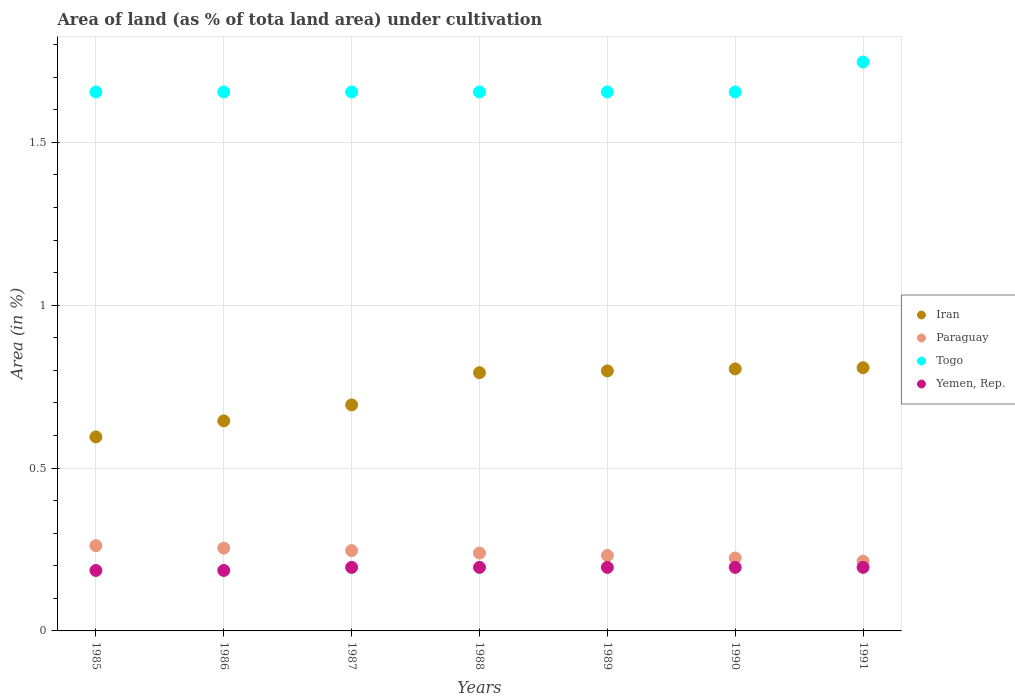How many different coloured dotlines are there?
Provide a succinct answer. 4. Is the number of dotlines equal to the number of legend labels?
Give a very brief answer. Yes. What is the percentage of land under cultivation in Yemen, Rep. in 1989?
Keep it short and to the point. 0.2. Across all years, what is the maximum percentage of land under cultivation in Paraguay?
Your response must be concise. 0.26. Across all years, what is the minimum percentage of land under cultivation in Togo?
Provide a succinct answer. 1.65. In which year was the percentage of land under cultivation in Togo minimum?
Your answer should be compact. 1985. What is the total percentage of land under cultivation in Iran in the graph?
Your response must be concise. 5.14. What is the difference between the percentage of land under cultivation in Iran in 1987 and that in 1991?
Make the answer very short. -0.11. What is the difference between the percentage of land under cultivation in Paraguay in 1985 and the percentage of land under cultivation in Yemen, Rep. in 1986?
Offer a terse response. 0.08. What is the average percentage of land under cultivation in Paraguay per year?
Keep it short and to the point. 0.24. In the year 1986, what is the difference between the percentage of land under cultivation in Yemen, Rep. and percentage of land under cultivation in Paraguay?
Make the answer very short. -0.07. In how many years, is the percentage of land under cultivation in Yemen, Rep. greater than 1.4 %?
Your answer should be compact. 0. What is the ratio of the percentage of land under cultivation in Paraguay in 1990 to that in 1991?
Your answer should be compact. 1.05. Is the difference between the percentage of land under cultivation in Yemen, Rep. in 1988 and 1989 greater than the difference between the percentage of land under cultivation in Paraguay in 1988 and 1989?
Your answer should be compact. No. What is the difference between the highest and the second highest percentage of land under cultivation in Iran?
Provide a short and direct response. 0. What is the difference between the highest and the lowest percentage of land under cultivation in Yemen, Rep.?
Offer a terse response. 0.01. In how many years, is the percentage of land under cultivation in Yemen, Rep. greater than the average percentage of land under cultivation in Yemen, Rep. taken over all years?
Your response must be concise. 5. Is it the case that in every year, the sum of the percentage of land under cultivation in Yemen, Rep. and percentage of land under cultivation in Togo  is greater than the sum of percentage of land under cultivation in Iran and percentage of land under cultivation in Paraguay?
Offer a very short reply. Yes. Is it the case that in every year, the sum of the percentage of land under cultivation in Iran and percentage of land under cultivation in Togo  is greater than the percentage of land under cultivation in Yemen, Rep.?
Offer a very short reply. Yes. Is the percentage of land under cultivation in Yemen, Rep. strictly greater than the percentage of land under cultivation in Iran over the years?
Keep it short and to the point. No. How many dotlines are there?
Provide a short and direct response. 4. What is the title of the graph?
Offer a very short reply. Area of land (as % of tota land area) under cultivation. What is the label or title of the X-axis?
Your answer should be very brief. Years. What is the label or title of the Y-axis?
Offer a very short reply. Area (in %). What is the Area (in %) in Iran in 1985?
Provide a short and direct response. 0.6. What is the Area (in %) in Paraguay in 1985?
Give a very brief answer. 0.26. What is the Area (in %) of Togo in 1985?
Ensure brevity in your answer.  1.65. What is the Area (in %) of Yemen, Rep. in 1985?
Your answer should be compact. 0.19. What is the Area (in %) of Iran in 1986?
Offer a terse response. 0.64. What is the Area (in %) in Paraguay in 1986?
Provide a succinct answer. 0.25. What is the Area (in %) of Togo in 1986?
Your answer should be very brief. 1.65. What is the Area (in %) of Yemen, Rep. in 1986?
Provide a short and direct response. 0.19. What is the Area (in %) of Iran in 1987?
Give a very brief answer. 0.69. What is the Area (in %) of Paraguay in 1987?
Offer a terse response. 0.25. What is the Area (in %) in Togo in 1987?
Offer a terse response. 1.65. What is the Area (in %) of Yemen, Rep. in 1987?
Your response must be concise. 0.2. What is the Area (in %) of Iran in 1988?
Ensure brevity in your answer.  0.79. What is the Area (in %) of Paraguay in 1988?
Your answer should be very brief. 0.24. What is the Area (in %) in Togo in 1988?
Offer a terse response. 1.65. What is the Area (in %) of Yemen, Rep. in 1988?
Offer a very short reply. 0.2. What is the Area (in %) in Iran in 1989?
Provide a succinct answer. 0.8. What is the Area (in %) of Paraguay in 1989?
Give a very brief answer. 0.23. What is the Area (in %) in Togo in 1989?
Your answer should be compact. 1.65. What is the Area (in %) in Yemen, Rep. in 1989?
Keep it short and to the point. 0.2. What is the Area (in %) in Iran in 1990?
Make the answer very short. 0.8. What is the Area (in %) of Paraguay in 1990?
Provide a short and direct response. 0.22. What is the Area (in %) of Togo in 1990?
Give a very brief answer. 1.65. What is the Area (in %) in Yemen, Rep. in 1990?
Keep it short and to the point. 0.2. What is the Area (in %) of Iran in 1991?
Your response must be concise. 0.81. What is the Area (in %) of Paraguay in 1991?
Give a very brief answer. 0.21. What is the Area (in %) in Togo in 1991?
Keep it short and to the point. 1.75. What is the Area (in %) of Yemen, Rep. in 1991?
Give a very brief answer. 0.2. Across all years, what is the maximum Area (in %) in Iran?
Give a very brief answer. 0.81. Across all years, what is the maximum Area (in %) in Paraguay?
Ensure brevity in your answer.  0.26. Across all years, what is the maximum Area (in %) of Togo?
Offer a terse response. 1.75. Across all years, what is the maximum Area (in %) in Yemen, Rep.?
Your response must be concise. 0.2. Across all years, what is the minimum Area (in %) in Iran?
Make the answer very short. 0.6. Across all years, what is the minimum Area (in %) in Paraguay?
Give a very brief answer. 0.21. Across all years, what is the minimum Area (in %) of Togo?
Your answer should be compact. 1.65. Across all years, what is the minimum Area (in %) of Yemen, Rep.?
Offer a very short reply. 0.19. What is the total Area (in %) in Iran in the graph?
Keep it short and to the point. 5.14. What is the total Area (in %) of Paraguay in the graph?
Provide a short and direct response. 1.67. What is the total Area (in %) in Togo in the graph?
Ensure brevity in your answer.  11.67. What is the total Area (in %) in Yemen, Rep. in the graph?
Provide a short and direct response. 1.35. What is the difference between the Area (in %) of Iran in 1985 and that in 1986?
Provide a short and direct response. -0.05. What is the difference between the Area (in %) of Paraguay in 1985 and that in 1986?
Your answer should be very brief. 0.01. What is the difference between the Area (in %) in Yemen, Rep. in 1985 and that in 1986?
Offer a very short reply. 0. What is the difference between the Area (in %) of Iran in 1985 and that in 1987?
Keep it short and to the point. -0.1. What is the difference between the Area (in %) of Paraguay in 1985 and that in 1987?
Provide a succinct answer. 0.02. What is the difference between the Area (in %) in Togo in 1985 and that in 1987?
Provide a succinct answer. 0. What is the difference between the Area (in %) of Yemen, Rep. in 1985 and that in 1987?
Your answer should be compact. -0.01. What is the difference between the Area (in %) of Iran in 1985 and that in 1988?
Your answer should be compact. -0.2. What is the difference between the Area (in %) in Paraguay in 1985 and that in 1988?
Provide a succinct answer. 0.02. What is the difference between the Area (in %) of Togo in 1985 and that in 1988?
Offer a terse response. 0. What is the difference between the Area (in %) in Yemen, Rep. in 1985 and that in 1988?
Provide a succinct answer. -0.01. What is the difference between the Area (in %) in Iran in 1985 and that in 1989?
Your answer should be very brief. -0.2. What is the difference between the Area (in %) of Paraguay in 1985 and that in 1989?
Provide a succinct answer. 0.03. What is the difference between the Area (in %) of Togo in 1985 and that in 1989?
Give a very brief answer. 0. What is the difference between the Area (in %) in Yemen, Rep. in 1985 and that in 1989?
Make the answer very short. -0.01. What is the difference between the Area (in %) of Iran in 1985 and that in 1990?
Provide a succinct answer. -0.21. What is the difference between the Area (in %) of Paraguay in 1985 and that in 1990?
Provide a short and direct response. 0.04. What is the difference between the Area (in %) of Yemen, Rep. in 1985 and that in 1990?
Provide a succinct answer. -0.01. What is the difference between the Area (in %) of Iran in 1985 and that in 1991?
Give a very brief answer. -0.21. What is the difference between the Area (in %) of Paraguay in 1985 and that in 1991?
Your answer should be very brief. 0.05. What is the difference between the Area (in %) of Togo in 1985 and that in 1991?
Offer a very short reply. -0.09. What is the difference between the Area (in %) in Yemen, Rep. in 1985 and that in 1991?
Your answer should be very brief. -0.01. What is the difference between the Area (in %) in Iran in 1986 and that in 1987?
Give a very brief answer. -0.05. What is the difference between the Area (in %) of Paraguay in 1986 and that in 1987?
Keep it short and to the point. 0.01. What is the difference between the Area (in %) of Togo in 1986 and that in 1987?
Give a very brief answer. 0. What is the difference between the Area (in %) in Yemen, Rep. in 1986 and that in 1987?
Provide a short and direct response. -0.01. What is the difference between the Area (in %) in Iran in 1986 and that in 1988?
Keep it short and to the point. -0.15. What is the difference between the Area (in %) in Paraguay in 1986 and that in 1988?
Offer a very short reply. 0.02. What is the difference between the Area (in %) in Togo in 1986 and that in 1988?
Keep it short and to the point. 0. What is the difference between the Area (in %) in Yemen, Rep. in 1986 and that in 1988?
Keep it short and to the point. -0.01. What is the difference between the Area (in %) of Iran in 1986 and that in 1989?
Give a very brief answer. -0.15. What is the difference between the Area (in %) of Paraguay in 1986 and that in 1989?
Provide a succinct answer. 0.02. What is the difference between the Area (in %) of Yemen, Rep. in 1986 and that in 1989?
Your answer should be very brief. -0.01. What is the difference between the Area (in %) in Iran in 1986 and that in 1990?
Make the answer very short. -0.16. What is the difference between the Area (in %) of Paraguay in 1986 and that in 1990?
Your response must be concise. 0.03. What is the difference between the Area (in %) of Yemen, Rep. in 1986 and that in 1990?
Offer a terse response. -0.01. What is the difference between the Area (in %) in Iran in 1986 and that in 1991?
Your answer should be compact. -0.16. What is the difference between the Area (in %) in Paraguay in 1986 and that in 1991?
Keep it short and to the point. 0.04. What is the difference between the Area (in %) in Togo in 1986 and that in 1991?
Your answer should be very brief. -0.09. What is the difference between the Area (in %) in Yemen, Rep. in 1986 and that in 1991?
Provide a short and direct response. -0.01. What is the difference between the Area (in %) in Iran in 1987 and that in 1988?
Your response must be concise. -0.1. What is the difference between the Area (in %) in Paraguay in 1987 and that in 1988?
Keep it short and to the point. 0.01. What is the difference between the Area (in %) in Togo in 1987 and that in 1988?
Give a very brief answer. 0. What is the difference between the Area (in %) in Iran in 1987 and that in 1989?
Offer a terse response. -0.1. What is the difference between the Area (in %) in Paraguay in 1987 and that in 1989?
Provide a succinct answer. 0.02. What is the difference between the Area (in %) of Togo in 1987 and that in 1989?
Keep it short and to the point. 0. What is the difference between the Area (in %) of Iran in 1987 and that in 1990?
Provide a short and direct response. -0.11. What is the difference between the Area (in %) of Paraguay in 1987 and that in 1990?
Make the answer very short. 0.02. What is the difference between the Area (in %) in Yemen, Rep. in 1987 and that in 1990?
Provide a succinct answer. 0. What is the difference between the Area (in %) in Iran in 1987 and that in 1991?
Offer a terse response. -0.11. What is the difference between the Area (in %) of Paraguay in 1987 and that in 1991?
Offer a terse response. 0.03. What is the difference between the Area (in %) of Togo in 1987 and that in 1991?
Keep it short and to the point. -0.09. What is the difference between the Area (in %) in Iran in 1988 and that in 1989?
Provide a succinct answer. -0.01. What is the difference between the Area (in %) of Paraguay in 1988 and that in 1989?
Your answer should be very brief. 0.01. What is the difference between the Area (in %) in Togo in 1988 and that in 1989?
Provide a short and direct response. 0. What is the difference between the Area (in %) of Yemen, Rep. in 1988 and that in 1989?
Your answer should be very brief. 0. What is the difference between the Area (in %) of Iran in 1988 and that in 1990?
Provide a short and direct response. -0.01. What is the difference between the Area (in %) of Paraguay in 1988 and that in 1990?
Keep it short and to the point. 0.02. What is the difference between the Area (in %) of Iran in 1988 and that in 1991?
Give a very brief answer. -0.02. What is the difference between the Area (in %) of Paraguay in 1988 and that in 1991?
Make the answer very short. 0.03. What is the difference between the Area (in %) in Togo in 1988 and that in 1991?
Ensure brevity in your answer.  -0.09. What is the difference between the Area (in %) of Yemen, Rep. in 1988 and that in 1991?
Make the answer very short. 0. What is the difference between the Area (in %) in Iran in 1989 and that in 1990?
Give a very brief answer. -0.01. What is the difference between the Area (in %) of Paraguay in 1989 and that in 1990?
Offer a terse response. 0.01. What is the difference between the Area (in %) in Iran in 1989 and that in 1991?
Give a very brief answer. -0.01. What is the difference between the Area (in %) in Paraguay in 1989 and that in 1991?
Give a very brief answer. 0.02. What is the difference between the Area (in %) of Togo in 1989 and that in 1991?
Offer a terse response. -0.09. What is the difference between the Area (in %) of Yemen, Rep. in 1989 and that in 1991?
Keep it short and to the point. 0. What is the difference between the Area (in %) of Iran in 1990 and that in 1991?
Your answer should be compact. -0. What is the difference between the Area (in %) of Paraguay in 1990 and that in 1991?
Provide a short and direct response. 0.01. What is the difference between the Area (in %) in Togo in 1990 and that in 1991?
Give a very brief answer. -0.09. What is the difference between the Area (in %) in Iran in 1985 and the Area (in %) in Paraguay in 1986?
Your answer should be very brief. 0.34. What is the difference between the Area (in %) in Iran in 1985 and the Area (in %) in Togo in 1986?
Offer a terse response. -1.06. What is the difference between the Area (in %) in Iran in 1985 and the Area (in %) in Yemen, Rep. in 1986?
Make the answer very short. 0.41. What is the difference between the Area (in %) of Paraguay in 1985 and the Area (in %) of Togo in 1986?
Your response must be concise. -1.39. What is the difference between the Area (in %) in Paraguay in 1985 and the Area (in %) in Yemen, Rep. in 1986?
Your answer should be very brief. 0.08. What is the difference between the Area (in %) in Togo in 1985 and the Area (in %) in Yemen, Rep. in 1986?
Provide a succinct answer. 1.47. What is the difference between the Area (in %) of Iran in 1985 and the Area (in %) of Paraguay in 1987?
Provide a succinct answer. 0.35. What is the difference between the Area (in %) of Iran in 1985 and the Area (in %) of Togo in 1987?
Provide a succinct answer. -1.06. What is the difference between the Area (in %) in Iran in 1985 and the Area (in %) in Yemen, Rep. in 1987?
Provide a succinct answer. 0.4. What is the difference between the Area (in %) of Paraguay in 1985 and the Area (in %) of Togo in 1987?
Offer a terse response. -1.39. What is the difference between the Area (in %) of Paraguay in 1985 and the Area (in %) of Yemen, Rep. in 1987?
Your answer should be compact. 0.07. What is the difference between the Area (in %) in Togo in 1985 and the Area (in %) in Yemen, Rep. in 1987?
Provide a succinct answer. 1.46. What is the difference between the Area (in %) of Iran in 1985 and the Area (in %) of Paraguay in 1988?
Your response must be concise. 0.36. What is the difference between the Area (in %) in Iran in 1985 and the Area (in %) in Togo in 1988?
Keep it short and to the point. -1.06. What is the difference between the Area (in %) of Iran in 1985 and the Area (in %) of Yemen, Rep. in 1988?
Your answer should be very brief. 0.4. What is the difference between the Area (in %) of Paraguay in 1985 and the Area (in %) of Togo in 1988?
Offer a very short reply. -1.39. What is the difference between the Area (in %) of Paraguay in 1985 and the Area (in %) of Yemen, Rep. in 1988?
Offer a very short reply. 0.07. What is the difference between the Area (in %) in Togo in 1985 and the Area (in %) in Yemen, Rep. in 1988?
Give a very brief answer. 1.46. What is the difference between the Area (in %) of Iran in 1985 and the Area (in %) of Paraguay in 1989?
Provide a short and direct response. 0.36. What is the difference between the Area (in %) in Iran in 1985 and the Area (in %) in Togo in 1989?
Your answer should be very brief. -1.06. What is the difference between the Area (in %) in Iran in 1985 and the Area (in %) in Yemen, Rep. in 1989?
Make the answer very short. 0.4. What is the difference between the Area (in %) of Paraguay in 1985 and the Area (in %) of Togo in 1989?
Offer a terse response. -1.39. What is the difference between the Area (in %) in Paraguay in 1985 and the Area (in %) in Yemen, Rep. in 1989?
Provide a succinct answer. 0.07. What is the difference between the Area (in %) in Togo in 1985 and the Area (in %) in Yemen, Rep. in 1989?
Keep it short and to the point. 1.46. What is the difference between the Area (in %) in Iran in 1985 and the Area (in %) in Paraguay in 1990?
Give a very brief answer. 0.37. What is the difference between the Area (in %) in Iran in 1985 and the Area (in %) in Togo in 1990?
Offer a terse response. -1.06. What is the difference between the Area (in %) in Iran in 1985 and the Area (in %) in Yemen, Rep. in 1990?
Make the answer very short. 0.4. What is the difference between the Area (in %) of Paraguay in 1985 and the Area (in %) of Togo in 1990?
Make the answer very short. -1.39. What is the difference between the Area (in %) in Paraguay in 1985 and the Area (in %) in Yemen, Rep. in 1990?
Ensure brevity in your answer.  0.07. What is the difference between the Area (in %) in Togo in 1985 and the Area (in %) in Yemen, Rep. in 1990?
Ensure brevity in your answer.  1.46. What is the difference between the Area (in %) of Iran in 1985 and the Area (in %) of Paraguay in 1991?
Offer a very short reply. 0.38. What is the difference between the Area (in %) in Iran in 1985 and the Area (in %) in Togo in 1991?
Give a very brief answer. -1.15. What is the difference between the Area (in %) of Iran in 1985 and the Area (in %) of Yemen, Rep. in 1991?
Offer a terse response. 0.4. What is the difference between the Area (in %) of Paraguay in 1985 and the Area (in %) of Togo in 1991?
Ensure brevity in your answer.  -1.48. What is the difference between the Area (in %) in Paraguay in 1985 and the Area (in %) in Yemen, Rep. in 1991?
Your answer should be very brief. 0.07. What is the difference between the Area (in %) in Togo in 1985 and the Area (in %) in Yemen, Rep. in 1991?
Offer a terse response. 1.46. What is the difference between the Area (in %) of Iran in 1986 and the Area (in %) of Paraguay in 1987?
Offer a very short reply. 0.4. What is the difference between the Area (in %) of Iran in 1986 and the Area (in %) of Togo in 1987?
Your answer should be very brief. -1.01. What is the difference between the Area (in %) of Iran in 1986 and the Area (in %) of Yemen, Rep. in 1987?
Your answer should be very brief. 0.45. What is the difference between the Area (in %) in Paraguay in 1986 and the Area (in %) in Togo in 1987?
Offer a very short reply. -1.4. What is the difference between the Area (in %) in Paraguay in 1986 and the Area (in %) in Yemen, Rep. in 1987?
Keep it short and to the point. 0.06. What is the difference between the Area (in %) in Togo in 1986 and the Area (in %) in Yemen, Rep. in 1987?
Ensure brevity in your answer.  1.46. What is the difference between the Area (in %) in Iran in 1986 and the Area (in %) in Paraguay in 1988?
Give a very brief answer. 0.41. What is the difference between the Area (in %) of Iran in 1986 and the Area (in %) of Togo in 1988?
Your response must be concise. -1.01. What is the difference between the Area (in %) in Iran in 1986 and the Area (in %) in Yemen, Rep. in 1988?
Your answer should be compact. 0.45. What is the difference between the Area (in %) in Paraguay in 1986 and the Area (in %) in Togo in 1988?
Make the answer very short. -1.4. What is the difference between the Area (in %) of Paraguay in 1986 and the Area (in %) of Yemen, Rep. in 1988?
Ensure brevity in your answer.  0.06. What is the difference between the Area (in %) of Togo in 1986 and the Area (in %) of Yemen, Rep. in 1988?
Your response must be concise. 1.46. What is the difference between the Area (in %) of Iran in 1986 and the Area (in %) of Paraguay in 1989?
Offer a very short reply. 0.41. What is the difference between the Area (in %) of Iran in 1986 and the Area (in %) of Togo in 1989?
Provide a short and direct response. -1.01. What is the difference between the Area (in %) in Iran in 1986 and the Area (in %) in Yemen, Rep. in 1989?
Your answer should be very brief. 0.45. What is the difference between the Area (in %) of Paraguay in 1986 and the Area (in %) of Togo in 1989?
Give a very brief answer. -1.4. What is the difference between the Area (in %) of Paraguay in 1986 and the Area (in %) of Yemen, Rep. in 1989?
Make the answer very short. 0.06. What is the difference between the Area (in %) in Togo in 1986 and the Area (in %) in Yemen, Rep. in 1989?
Offer a terse response. 1.46. What is the difference between the Area (in %) of Iran in 1986 and the Area (in %) of Paraguay in 1990?
Provide a succinct answer. 0.42. What is the difference between the Area (in %) in Iran in 1986 and the Area (in %) in Togo in 1990?
Make the answer very short. -1.01. What is the difference between the Area (in %) of Iran in 1986 and the Area (in %) of Yemen, Rep. in 1990?
Make the answer very short. 0.45. What is the difference between the Area (in %) in Paraguay in 1986 and the Area (in %) in Togo in 1990?
Your answer should be compact. -1.4. What is the difference between the Area (in %) of Paraguay in 1986 and the Area (in %) of Yemen, Rep. in 1990?
Your answer should be very brief. 0.06. What is the difference between the Area (in %) in Togo in 1986 and the Area (in %) in Yemen, Rep. in 1990?
Give a very brief answer. 1.46. What is the difference between the Area (in %) in Iran in 1986 and the Area (in %) in Paraguay in 1991?
Your response must be concise. 0.43. What is the difference between the Area (in %) of Iran in 1986 and the Area (in %) of Togo in 1991?
Give a very brief answer. -1.1. What is the difference between the Area (in %) in Iran in 1986 and the Area (in %) in Yemen, Rep. in 1991?
Your response must be concise. 0.45. What is the difference between the Area (in %) of Paraguay in 1986 and the Area (in %) of Togo in 1991?
Offer a very short reply. -1.49. What is the difference between the Area (in %) of Paraguay in 1986 and the Area (in %) of Yemen, Rep. in 1991?
Give a very brief answer. 0.06. What is the difference between the Area (in %) of Togo in 1986 and the Area (in %) of Yemen, Rep. in 1991?
Keep it short and to the point. 1.46. What is the difference between the Area (in %) in Iran in 1987 and the Area (in %) in Paraguay in 1988?
Your response must be concise. 0.45. What is the difference between the Area (in %) in Iran in 1987 and the Area (in %) in Togo in 1988?
Your answer should be very brief. -0.96. What is the difference between the Area (in %) in Iran in 1987 and the Area (in %) in Yemen, Rep. in 1988?
Give a very brief answer. 0.5. What is the difference between the Area (in %) in Paraguay in 1987 and the Area (in %) in Togo in 1988?
Offer a very short reply. -1.41. What is the difference between the Area (in %) in Paraguay in 1987 and the Area (in %) in Yemen, Rep. in 1988?
Offer a terse response. 0.05. What is the difference between the Area (in %) of Togo in 1987 and the Area (in %) of Yemen, Rep. in 1988?
Make the answer very short. 1.46. What is the difference between the Area (in %) in Iran in 1987 and the Area (in %) in Paraguay in 1989?
Your response must be concise. 0.46. What is the difference between the Area (in %) in Iran in 1987 and the Area (in %) in Togo in 1989?
Keep it short and to the point. -0.96. What is the difference between the Area (in %) in Iran in 1987 and the Area (in %) in Yemen, Rep. in 1989?
Offer a very short reply. 0.5. What is the difference between the Area (in %) in Paraguay in 1987 and the Area (in %) in Togo in 1989?
Provide a short and direct response. -1.41. What is the difference between the Area (in %) in Paraguay in 1987 and the Area (in %) in Yemen, Rep. in 1989?
Your answer should be compact. 0.05. What is the difference between the Area (in %) in Togo in 1987 and the Area (in %) in Yemen, Rep. in 1989?
Your answer should be compact. 1.46. What is the difference between the Area (in %) of Iran in 1987 and the Area (in %) of Paraguay in 1990?
Offer a very short reply. 0.47. What is the difference between the Area (in %) in Iran in 1987 and the Area (in %) in Togo in 1990?
Give a very brief answer. -0.96. What is the difference between the Area (in %) of Iran in 1987 and the Area (in %) of Yemen, Rep. in 1990?
Your answer should be very brief. 0.5. What is the difference between the Area (in %) in Paraguay in 1987 and the Area (in %) in Togo in 1990?
Provide a succinct answer. -1.41. What is the difference between the Area (in %) of Paraguay in 1987 and the Area (in %) of Yemen, Rep. in 1990?
Provide a short and direct response. 0.05. What is the difference between the Area (in %) in Togo in 1987 and the Area (in %) in Yemen, Rep. in 1990?
Keep it short and to the point. 1.46. What is the difference between the Area (in %) in Iran in 1987 and the Area (in %) in Paraguay in 1991?
Your answer should be very brief. 0.48. What is the difference between the Area (in %) of Iran in 1987 and the Area (in %) of Togo in 1991?
Provide a short and direct response. -1.05. What is the difference between the Area (in %) of Iran in 1987 and the Area (in %) of Yemen, Rep. in 1991?
Your answer should be compact. 0.5. What is the difference between the Area (in %) in Paraguay in 1987 and the Area (in %) in Yemen, Rep. in 1991?
Offer a very short reply. 0.05. What is the difference between the Area (in %) of Togo in 1987 and the Area (in %) of Yemen, Rep. in 1991?
Your answer should be compact. 1.46. What is the difference between the Area (in %) of Iran in 1988 and the Area (in %) of Paraguay in 1989?
Your response must be concise. 0.56. What is the difference between the Area (in %) of Iran in 1988 and the Area (in %) of Togo in 1989?
Your answer should be very brief. -0.86. What is the difference between the Area (in %) in Iran in 1988 and the Area (in %) in Yemen, Rep. in 1989?
Offer a very short reply. 0.6. What is the difference between the Area (in %) of Paraguay in 1988 and the Area (in %) of Togo in 1989?
Your response must be concise. -1.42. What is the difference between the Area (in %) in Paraguay in 1988 and the Area (in %) in Yemen, Rep. in 1989?
Make the answer very short. 0.04. What is the difference between the Area (in %) of Togo in 1988 and the Area (in %) of Yemen, Rep. in 1989?
Keep it short and to the point. 1.46. What is the difference between the Area (in %) of Iran in 1988 and the Area (in %) of Paraguay in 1990?
Your answer should be compact. 0.57. What is the difference between the Area (in %) of Iran in 1988 and the Area (in %) of Togo in 1990?
Your response must be concise. -0.86. What is the difference between the Area (in %) of Iran in 1988 and the Area (in %) of Yemen, Rep. in 1990?
Give a very brief answer. 0.6. What is the difference between the Area (in %) of Paraguay in 1988 and the Area (in %) of Togo in 1990?
Provide a succinct answer. -1.42. What is the difference between the Area (in %) of Paraguay in 1988 and the Area (in %) of Yemen, Rep. in 1990?
Offer a terse response. 0.04. What is the difference between the Area (in %) of Togo in 1988 and the Area (in %) of Yemen, Rep. in 1990?
Provide a short and direct response. 1.46. What is the difference between the Area (in %) of Iran in 1988 and the Area (in %) of Paraguay in 1991?
Keep it short and to the point. 0.58. What is the difference between the Area (in %) of Iran in 1988 and the Area (in %) of Togo in 1991?
Provide a succinct answer. -0.95. What is the difference between the Area (in %) of Iran in 1988 and the Area (in %) of Yemen, Rep. in 1991?
Your answer should be very brief. 0.6. What is the difference between the Area (in %) of Paraguay in 1988 and the Area (in %) of Togo in 1991?
Give a very brief answer. -1.51. What is the difference between the Area (in %) in Paraguay in 1988 and the Area (in %) in Yemen, Rep. in 1991?
Offer a very short reply. 0.04. What is the difference between the Area (in %) in Togo in 1988 and the Area (in %) in Yemen, Rep. in 1991?
Offer a very short reply. 1.46. What is the difference between the Area (in %) in Iran in 1989 and the Area (in %) in Paraguay in 1990?
Offer a very short reply. 0.57. What is the difference between the Area (in %) of Iran in 1989 and the Area (in %) of Togo in 1990?
Keep it short and to the point. -0.86. What is the difference between the Area (in %) in Iran in 1989 and the Area (in %) in Yemen, Rep. in 1990?
Your answer should be very brief. 0.6. What is the difference between the Area (in %) in Paraguay in 1989 and the Area (in %) in Togo in 1990?
Offer a terse response. -1.42. What is the difference between the Area (in %) in Paraguay in 1989 and the Area (in %) in Yemen, Rep. in 1990?
Provide a succinct answer. 0.04. What is the difference between the Area (in %) of Togo in 1989 and the Area (in %) of Yemen, Rep. in 1990?
Provide a succinct answer. 1.46. What is the difference between the Area (in %) of Iran in 1989 and the Area (in %) of Paraguay in 1991?
Provide a short and direct response. 0.58. What is the difference between the Area (in %) of Iran in 1989 and the Area (in %) of Togo in 1991?
Your answer should be compact. -0.95. What is the difference between the Area (in %) in Iran in 1989 and the Area (in %) in Yemen, Rep. in 1991?
Your answer should be very brief. 0.6. What is the difference between the Area (in %) in Paraguay in 1989 and the Area (in %) in Togo in 1991?
Your answer should be compact. -1.52. What is the difference between the Area (in %) of Paraguay in 1989 and the Area (in %) of Yemen, Rep. in 1991?
Your answer should be very brief. 0.04. What is the difference between the Area (in %) of Togo in 1989 and the Area (in %) of Yemen, Rep. in 1991?
Give a very brief answer. 1.46. What is the difference between the Area (in %) in Iran in 1990 and the Area (in %) in Paraguay in 1991?
Make the answer very short. 0.59. What is the difference between the Area (in %) of Iran in 1990 and the Area (in %) of Togo in 1991?
Offer a very short reply. -0.94. What is the difference between the Area (in %) of Iran in 1990 and the Area (in %) of Yemen, Rep. in 1991?
Keep it short and to the point. 0.61. What is the difference between the Area (in %) in Paraguay in 1990 and the Area (in %) in Togo in 1991?
Make the answer very short. -1.52. What is the difference between the Area (in %) in Paraguay in 1990 and the Area (in %) in Yemen, Rep. in 1991?
Your response must be concise. 0.03. What is the difference between the Area (in %) in Togo in 1990 and the Area (in %) in Yemen, Rep. in 1991?
Provide a succinct answer. 1.46. What is the average Area (in %) in Iran per year?
Give a very brief answer. 0.73. What is the average Area (in %) in Paraguay per year?
Offer a very short reply. 0.24. What is the average Area (in %) in Togo per year?
Your answer should be very brief. 1.67. What is the average Area (in %) in Yemen, Rep. per year?
Offer a terse response. 0.19. In the year 1985, what is the difference between the Area (in %) in Iran and Area (in %) in Paraguay?
Your answer should be compact. 0.33. In the year 1985, what is the difference between the Area (in %) of Iran and Area (in %) of Togo?
Offer a terse response. -1.06. In the year 1985, what is the difference between the Area (in %) of Iran and Area (in %) of Yemen, Rep.?
Ensure brevity in your answer.  0.41. In the year 1985, what is the difference between the Area (in %) in Paraguay and Area (in %) in Togo?
Your response must be concise. -1.39. In the year 1985, what is the difference between the Area (in %) of Paraguay and Area (in %) of Yemen, Rep.?
Offer a terse response. 0.08. In the year 1985, what is the difference between the Area (in %) of Togo and Area (in %) of Yemen, Rep.?
Provide a succinct answer. 1.47. In the year 1986, what is the difference between the Area (in %) of Iran and Area (in %) of Paraguay?
Make the answer very short. 0.39. In the year 1986, what is the difference between the Area (in %) in Iran and Area (in %) in Togo?
Give a very brief answer. -1.01. In the year 1986, what is the difference between the Area (in %) in Iran and Area (in %) in Yemen, Rep.?
Your answer should be very brief. 0.46. In the year 1986, what is the difference between the Area (in %) of Paraguay and Area (in %) of Togo?
Offer a terse response. -1.4. In the year 1986, what is the difference between the Area (in %) of Paraguay and Area (in %) of Yemen, Rep.?
Make the answer very short. 0.07. In the year 1986, what is the difference between the Area (in %) in Togo and Area (in %) in Yemen, Rep.?
Provide a short and direct response. 1.47. In the year 1987, what is the difference between the Area (in %) in Iran and Area (in %) in Paraguay?
Offer a terse response. 0.45. In the year 1987, what is the difference between the Area (in %) in Iran and Area (in %) in Togo?
Ensure brevity in your answer.  -0.96. In the year 1987, what is the difference between the Area (in %) of Iran and Area (in %) of Yemen, Rep.?
Make the answer very short. 0.5. In the year 1987, what is the difference between the Area (in %) in Paraguay and Area (in %) in Togo?
Your answer should be very brief. -1.41. In the year 1987, what is the difference between the Area (in %) of Paraguay and Area (in %) of Yemen, Rep.?
Provide a succinct answer. 0.05. In the year 1987, what is the difference between the Area (in %) of Togo and Area (in %) of Yemen, Rep.?
Your answer should be very brief. 1.46. In the year 1988, what is the difference between the Area (in %) of Iran and Area (in %) of Paraguay?
Offer a terse response. 0.55. In the year 1988, what is the difference between the Area (in %) in Iran and Area (in %) in Togo?
Your response must be concise. -0.86. In the year 1988, what is the difference between the Area (in %) of Iran and Area (in %) of Yemen, Rep.?
Offer a terse response. 0.6. In the year 1988, what is the difference between the Area (in %) in Paraguay and Area (in %) in Togo?
Make the answer very short. -1.42. In the year 1988, what is the difference between the Area (in %) of Paraguay and Area (in %) of Yemen, Rep.?
Provide a short and direct response. 0.04. In the year 1988, what is the difference between the Area (in %) of Togo and Area (in %) of Yemen, Rep.?
Keep it short and to the point. 1.46. In the year 1989, what is the difference between the Area (in %) in Iran and Area (in %) in Paraguay?
Keep it short and to the point. 0.57. In the year 1989, what is the difference between the Area (in %) of Iran and Area (in %) of Togo?
Ensure brevity in your answer.  -0.86. In the year 1989, what is the difference between the Area (in %) of Iran and Area (in %) of Yemen, Rep.?
Your answer should be compact. 0.6. In the year 1989, what is the difference between the Area (in %) in Paraguay and Area (in %) in Togo?
Provide a succinct answer. -1.42. In the year 1989, what is the difference between the Area (in %) in Paraguay and Area (in %) in Yemen, Rep.?
Your response must be concise. 0.04. In the year 1989, what is the difference between the Area (in %) in Togo and Area (in %) in Yemen, Rep.?
Make the answer very short. 1.46. In the year 1990, what is the difference between the Area (in %) of Iran and Area (in %) of Paraguay?
Your answer should be very brief. 0.58. In the year 1990, what is the difference between the Area (in %) of Iran and Area (in %) of Togo?
Make the answer very short. -0.85. In the year 1990, what is the difference between the Area (in %) in Iran and Area (in %) in Yemen, Rep.?
Your response must be concise. 0.61. In the year 1990, what is the difference between the Area (in %) in Paraguay and Area (in %) in Togo?
Ensure brevity in your answer.  -1.43. In the year 1990, what is the difference between the Area (in %) of Paraguay and Area (in %) of Yemen, Rep.?
Make the answer very short. 0.03. In the year 1990, what is the difference between the Area (in %) of Togo and Area (in %) of Yemen, Rep.?
Give a very brief answer. 1.46. In the year 1991, what is the difference between the Area (in %) of Iran and Area (in %) of Paraguay?
Keep it short and to the point. 0.59. In the year 1991, what is the difference between the Area (in %) of Iran and Area (in %) of Togo?
Provide a short and direct response. -0.94. In the year 1991, what is the difference between the Area (in %) in Iran and Area (in %) in Yemen, Rep.?
Give a very brief answer. 0.61. In the year 1991, what is the difference between the Area (in %) in Paraguay and Area (in %) in Togo?
Give a very brief answer. -1.53. In the year 1991, what is the difference between the Area (in %) of Paraguay and Area (in %) of Yemen, Rep.?
Keep it short and to the point. 0.02. In the year 1991, what is the difference between the Area (in %) in Togo and Area (in %) in Yemen, Rep.?
Make the answer very short. 1.55. What is the ratio of the Area (in %) of Iran in 1985 to that in 1986?
Offer a very short reply. 0.92. What is the ratio of the Area (in %) of Paraguay in 1985 to that in 1986?
Provide a short and direct response. 1.03. What is the ratio of the Area (in %) in Yemen, Rep. in 1985 to that in 1986?
Keep it short and to the point. 1. What is the ratio of the Area (in %) of Iran in 1985 to that in 1987?
Offer a very short reply. 0.86. What is the ratio of the Area (in %) of Paraguay in 1985 to that in 1987?
Make the answer very short. 1.06. What is the ratio of the Area (in %) in Togo in 1985 to that in 1987?
Offer a very short reply. 1. What is the ratio of the Area (in %) in Yemen, Rep. in 1985 to that in 1987?
Provide a short and direct response. 0.95. What is the ratio of the Area (in %) of Iran in 1985 to that in 1988?
Ensure brevity in your answer.  0.75. What is the ratio of the Area (in %) in Paraguay in 1985 to that in 1988?
Give a very brief answer. 1.09. What is the ratio of the Area (in %) in Yemen, Rep. in 1985 to that in 1988?
Ensure brevity in your answer.  0.95. What is the ratio of the Area (in %) of Iran in 1985 to that in 1989?
Offer a very short reply. 0.75. What is the ratio of the Area (in %) of Paraguay in 1985 to that in 1989?
Keep it short and to the point. 1.13. What is the ratio of the Area (in %) in Yemen, Rep. in 1985 to that in 1989?
Ensure brevity in your answer.  0.95. What is the ratio of the Area (in %) in Iran in 1985 to that in 1990?
Provide a short and direct response. 0.74. What is the ratio of the Area (in %) of Paraguay in 1985 to that in 1990?
Make the answer very short. 1.17. What is the ratio of the Area (in %) in Togo in 1985 to that in 1990?
Provide a short and direct response. 1. What is the ratio of the Area (in %) of Yemen, Rep. in 1985 to that in 1990?
Make the answer very short. 0.95. What is the ratio of the Area (in %) in Iran in 1985 to that in 1991?
Keep it short and to the point. 0.74. What is the ratio of the Area (in %) of Paraguay in 1985 to that in 1991?
Your response must be concise. 1.22. What is the ratio of the Area (in %) in Yemen, Rep. in 1985 to that in 1991?
Give a very brief answer. 0.95. What is the ratio of the Area (in %) in Iran in 1986 to that in 1987?
Your response must be concise. 0.93. What is the ratio of the Area (in %) of Paraguay in 1986 to that in 1987?
Give a very brief answer. 1.03. What is the ratio of the Area (in %) of Togo in 1986 to that in 1987?
Your answer should be very brief. 1. What is the ratio of the Area (in %) in Yemen, Rep. in 1986 to that in 1987?
Offer a terse response. 0.95. What is the ratio of the Area (in %) in Iran in 1986 to that in 1988?
Offer a very short reply. 0.81. What is the ratio of the Area (in %) in Paraguay in 1986 to that in 1988?
Keep it short and to the point. 1.06. What is the ratio of the Area (in %) in Yemen, Rep. in 1986 to that in 1988?
Provide a short and direct response. 0.95. What is the ratio of the Area (in %) in Iran in 1986 to that in 1989?
Provide a succinct answer. 0.81. What is the ratio of the Area (in %) in Paraguay in 1986 to that in 1989?
Provide a short and direct response. 1.1. What is the ratio of the Area (in %) of Togo in 1986 to that in 1989?
Give a very brief answer. 1. What is the ratio of the Area (in %) in Yemen, Rep. in 1986 to that in 1989?
Your answer should be very brief. 0.95. What is the ratio of the Area (in %) in Iran in 1986 to that in 1990?
Offer a very short reply. 0.8. What is the ratio of the Area (in %) in Paraguay in 1986 to that in 1990?
Offer a very short reply. 1.13. What is the ratio of the Area (in %) of Togo in 1986 to that in 1990?
Ensure brevity in your answer.  1. What is the ratio of the Area (in %) of Yemen, Rep. in 1986 to that in 1990?
Offer a very short reply. 0.95. What is the ratio of the Area (in %) of Iran in 1986 to that in 1991?
Offer a terse response. 0.8. What is the ratio of the Area (in %) of Paraguay in 1986 to that in 1991?
Give a very brief answer. 1.19. What is the ratio of the Area (in %) of Yemen, Rep. in 1986 to that in 1991?
Keep it short and to the point. 0.95. What is the ratio of the Area (in %) of Iran in 1987 to that in 1988?
Offer a very short reply. 0.88. What is the ratio of the Area (in %) of Paraguay in 1987 to that in 1988?
Your answer should be compact. 1.03. What is the ratio of the Area (in %) of Togo in 1987 to that in 1988?
Your answer should be compact. 1. What is the ratio of the Area (in %) in Iran in 1987 to that in 1989?
Provide a short and direct response. 0.87. What is the ratio of the Area (in %) in Paraguay in 1987 to that in 1989?
Provide a short and direct response. 1.07. What is the ratio of the Area (in %) in Iran in 1987 to that in 1990?
Make the answer very short. 0.86. What is the ratio of the Area (in %) of Paraguay in 1987 to that in 1990?
Make the answer very short. 1.1. What is the ratio of the Area (in %) in Yemen, Rep. in 1987 to that in 1990?
Your answer should be very brief. 1. What is the ratio of the Area (in %) of Iran in 1987 to that in 1991?
Ensure brevity in your answer.  0.86. What is the ratio of the Area (in %) in Paraguay in 1987 to that in 1991?
Keep it short and to the point. 1.15. What is the ratio of the Area (in %) of Yemen, Rep. in 1987 to that in 1991?
Ensure brevity in your answer.  1. What is the ratio of the Area (in %) in Paraguay in 1988 to that in 1989?
Keep it short and to the point. 1.03. What is the ratio of the Area (in %) in Togo in 1988 to that in 1989?
Keep it short and to the point. 1. What is the ratio of the Area (in %) in Yemen, Rep. in 1988 to that in 1989?
Provide a short and direct response. 1. What is the ratio of the Area (in %) in Iran in 1988 to that in 1990?
Give a very brief answer. 0.99. What is the ratio of the Area (in %) in Paraguay in 1988 to that in 1990?
Ensure brevity in your answer.  1.07. What is the ratio of the Area (in %) of Yemen, Rep. in 1988 to that in 1990?
Your answer should be very brief. 1. What is the ratio of the Area (in %) of Iran in 1988 to that in 1991?
Offer a very short reply. 0.98. What is the ratio of the Area (in %) in Paraguay in 1988 to that in 1991?
Make the answer very short. 1.12. What is the ratio of the Area (in %) in Togo in 1988 to that in 1991?
Keep it short and to the point. 0.95. What is the ratio of the Area (in %) in Paraguay in 1989 to that in 1990?
Keep it short and to the point. 1.03. What is the ratio of the Area (in %) in Togo in 1989 to that in 1990?
Make the answer very short. 1. What is the ratio of the Area (in %) in Yemen, Rep. in 1989 to that in 1990?
Your answer should be very brief. 1. What is the ratio of the Area (in %) of Paraguay in 1989 to that in 1991?
Your answer should be very brief. 1.08. What is the ratio of the Area (in %) of Togo in 1989 to that in 1991?
Ensure brevity in your answer.  0.95. What is the ratio of the Area (in %) in Yemen, Rep. in 1989 to that in 1991?
Provide a short and direct response. 1. What is the ratio of the Area (in %) of Paraguay in 1990 to that in 1991?
Provide a short and direct response. 1.05. What is the ratio of the Area (in %) of Yemen, Rep. in 1990 to that in 1991?
Provide a short and direct response. 1. What is the difference between the highest and the second highest Area (in %) of Iran?
Your answer should be very brief. 0. What is the difference between the highest and the second highest Area (in %) of Paraguay?
Keep it short and to the point. 0.01. What is the difference between the highest and the second highest Area (in %) in Togo?
Provide a short and direct response. 0.09. What is the difference between the highest and the lowest Area (in %) of Iran?
Your answer should be very brief. 0.21. What is the difference between the highest and the lowest Area (in %) of Paraguay?
Give a very brief answer. 0.05. What is the difference between the highest and the lowest Area (in %) of Togo?
Offer a very short reply. 0.09. What is the difference between the highest and the lowest Area (in %) of Yemen, Rep.?
Your answer should be compact. 0.01. 